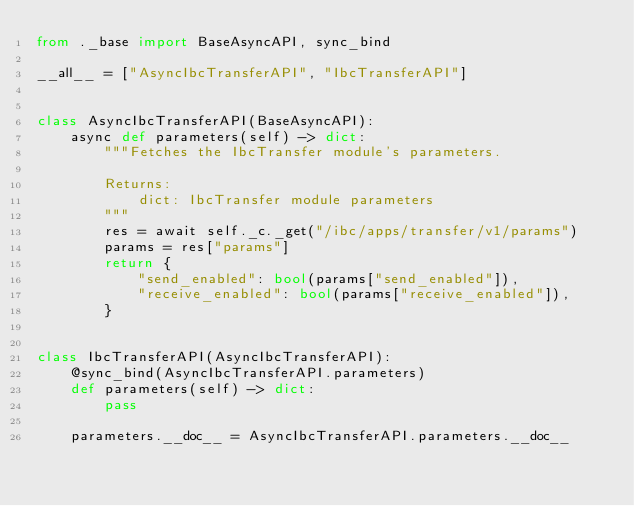Convert code to text. <code><loc_0><loc_0><loc_500><loc_500><_Python_>from ._base import BaseAsyncAPI, sync_bind

__all__ = ["AsyncIbcTransferAPI", "IbcTransferAPI"]


class AsyncIbcTransferAPI(BaseAsyncAPI):
    async def parameters(self) -> dict:
        """Fetches the IbcTransfer module's parameters.

        Returns:
            dict: IbcTransfer module parameters
        """
        res = await self._c._get("/ibc/apps/transfer/v1/params")
        params = res["params"]
        return {
            "send_enabled": bool(params["send_enabled"]),
            "receive_enabled": bool(params["receive_enabled"]),
        }


class IbcTransferAPI(AsyncIbcTransferAPI):
    @sync_bind(AsyncIbcTransferAPI.parameters)
    def parameters(self) -> dict:
        pass

    parameters.__doc__ = AsyncIbcTransferAPI.parameters.__doc__
</code> 